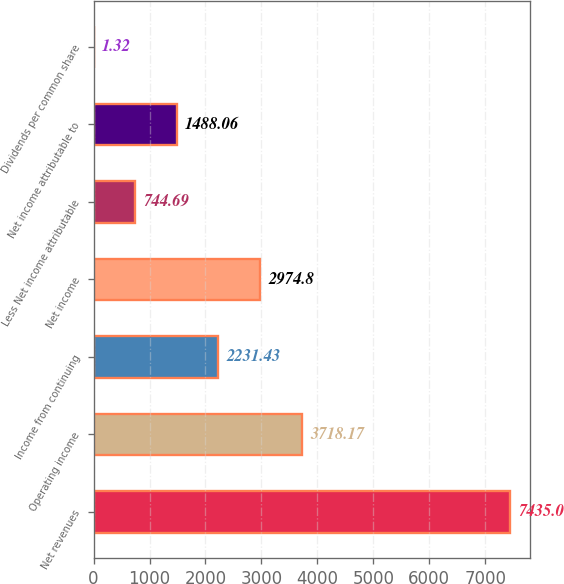Convert chart. <chart><loc_0><loc_0><loc_500><loc_500><bar_chart><fcel>Net revenues<fcel>Operating income<fcel>Income from continuing<fcel>Net income<fcel>Less Net income attributable<fcel>Net income attributable to<fcel>Dividends per common share<nl><fcel>7435<fcel>3718.17<fcel>2231.43<fcel>2974.8<fcel>744.69<fcel>1488.06<fcel>1.32<nl></chart> 